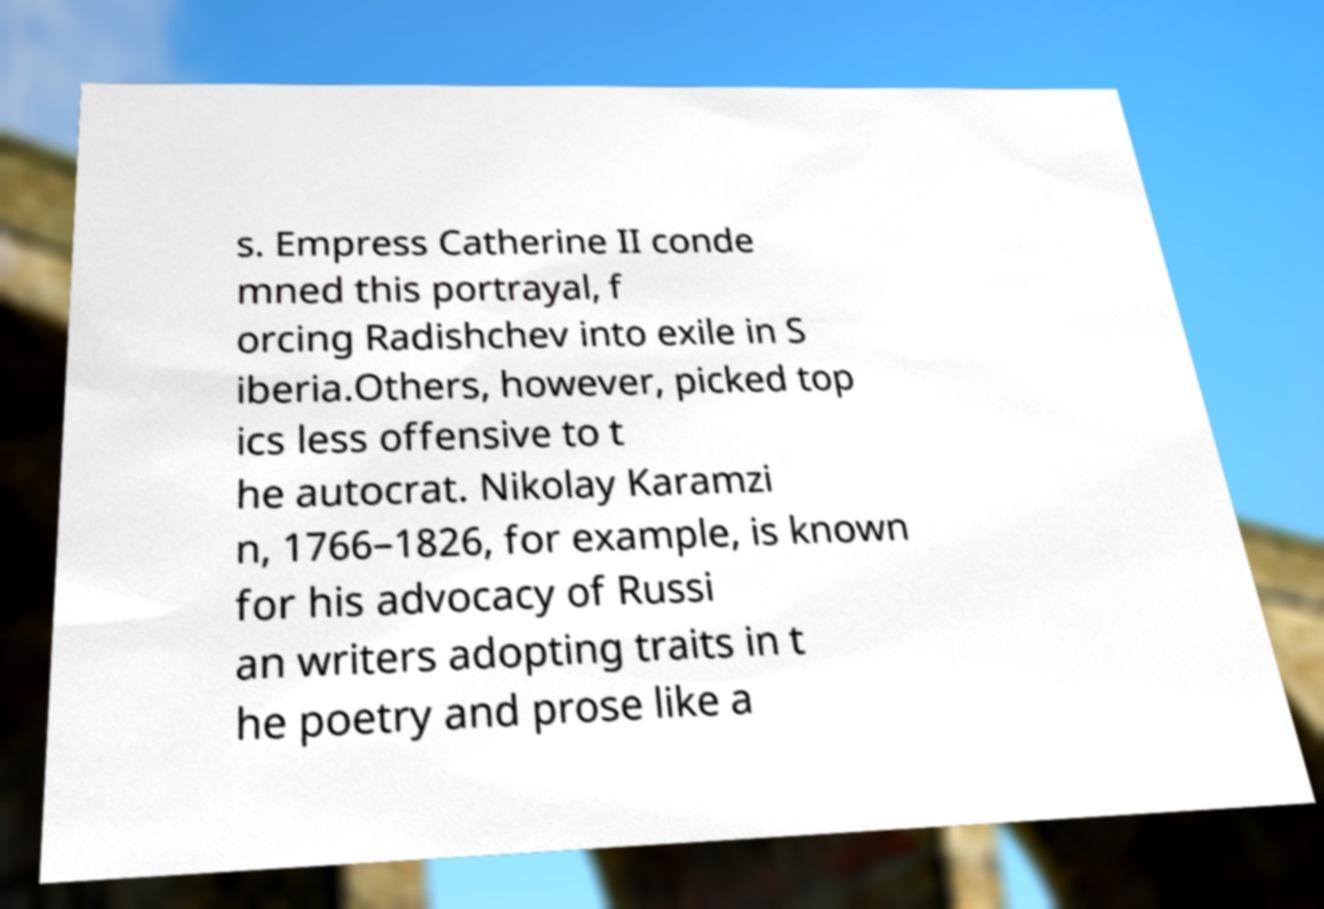For documentation purposes, I need the text within this image transcribed. Could you provide that? s. Empress Catherine II conde mned this portrayal, f orcing Radishchev into exile in S iberia.Others, however, picked top ics less offensive to t he autocrat. Nikolay Karamzi n, 1766–1826, for example, is known for his advocacy of Russi an writers adopting traits in t he poetry and prose like a 